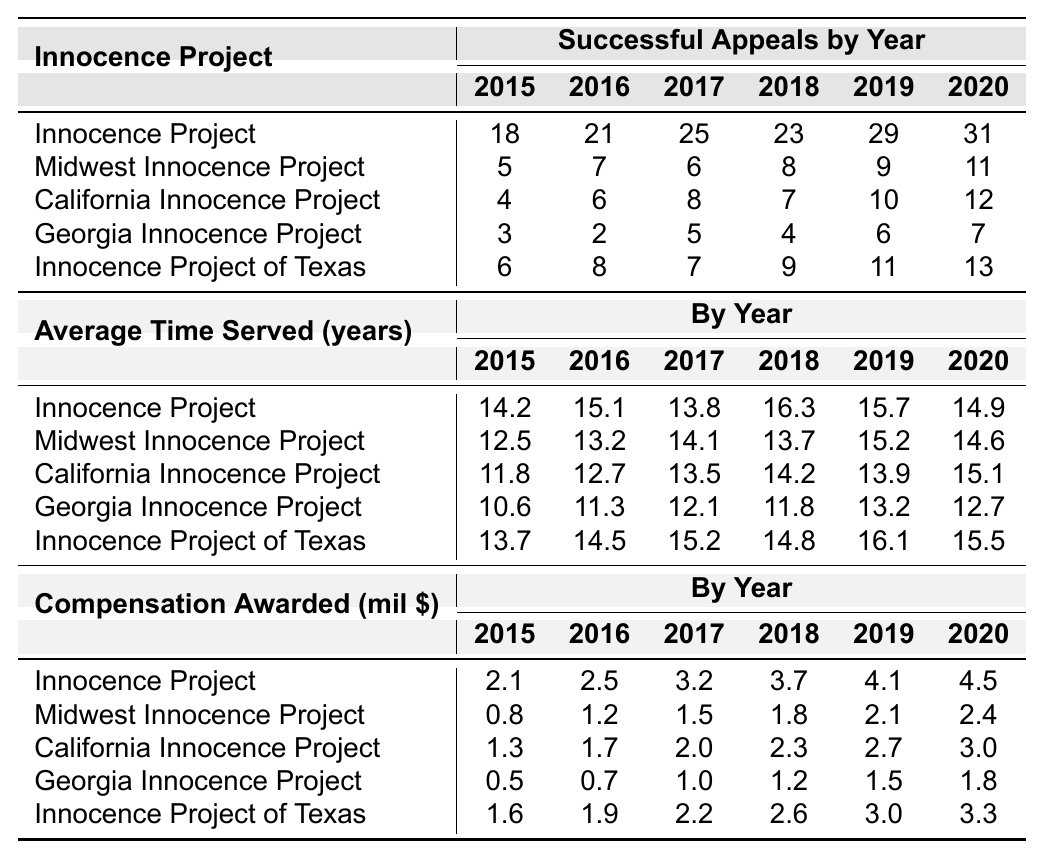What was the highest number of successful appeals in 2020? In 2020, the Innocence Project had the highest number of successful appeals, which is 31.
Answer: 31 Which innocence project had the lowest average time served in 2015? In 2015, the Georgia Innocence Project had the lowest average time served at 10.6 years compared to others.
Answer: 10.6 How many successful appeals were there in total across all projects in 2019? To find the total in 2019, add the successful appeals: 29 + 9 + 10 + 6 + 11 = 65.
Answer: 65 Is the average compensation awarded in 2018 higher than in 2016 for the California Innocence Project? In 2016, the compensation was 1.7 million, and in 2018 it was 2.3 million, so it is higher in 2018.
Answer: Yes Which innocence project had the highest average compensation awarded from 2015 to 2020? The Innocence Project had the highest average compensation of 3.3 million over the years.
Answer: Innocence Project What is the difference in compensation awarded between 2015 and 2020 for the Midwest Innocence Project? For the Midwest Innocence Project, the compensation awarded increased from 0.8 million in 2015 to 2.4 million in 2020, resulting in a difference of 2.4 - 0.8 = 1.6 million.
Answer: 1.6 million What is the average successful appeals per year for the Georgia Innocence Project from 2015 to 2020? Add the successful appeals from 2015 to 2020: 3 + 2 + 5 + 4 + 6 + 7 = 27, then divide by 6 years gives an average of 27/6 = 4.5.
Answer: 4.5 Did the California Innocence Project have an increase in successful appeals every year from 2015 to 2020? Looking at the yearly successful appeals, it shows 4, 6, 8, 7, 10, and 12, indicating it did not increase every year since it decreased from 8 to 7 in 2018.
Answer: No Which year saw the highest compensation awarded for the Innocence Project? In 2019, the compensation awarded was 4.1 million, which was the highest amount recorded for the Innocence Project.
Answer: 4.1 million What proportion of successful appeals did the Innocence Project achieve in 2019 out of the total successful appeals that year across all projects? The Innocence Project had 29 successful appeals in 2019, and the total across all projects was 65, giving a proportion of 29/65 which is approximately 44.6%.
Answer: About 44.6% 